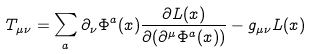<formula> <loc_0><loc_0><loc_500><loc_500>T _ { \mu \nu } = \sum _ { a } \partial _ { \nu } \Phi ^ { a } ( x ) \frac { \partial L ( x ) } { \partial ( \partial ^ { \mu } \Phi ^ { a } ( x ) ) } - g _ { \mu \nu } L ( x )</formula> 